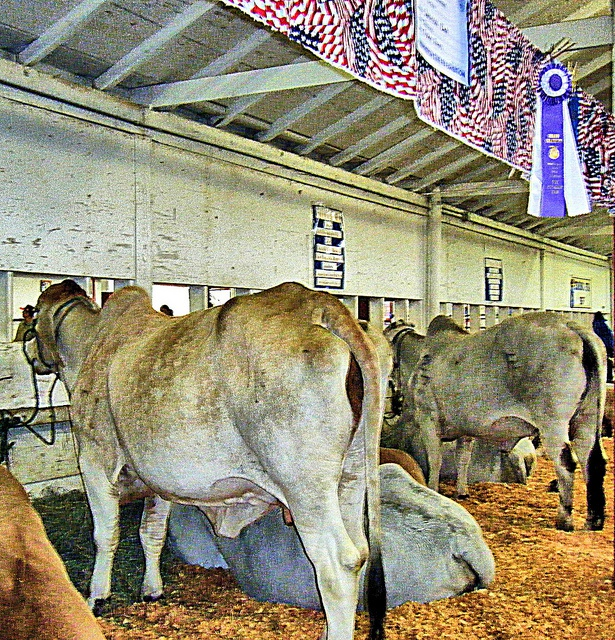Describe the objects in this image and their specific colors. I can see cow in gray, darkgray, tan, lightgray, and beige tones, cow in gray, olive, and black tones, cow in gray and darkgray tones, cow in gray, tan, olive, and maroon tones, and cow in gray, black, darkgreen, and olive tones in this image. 